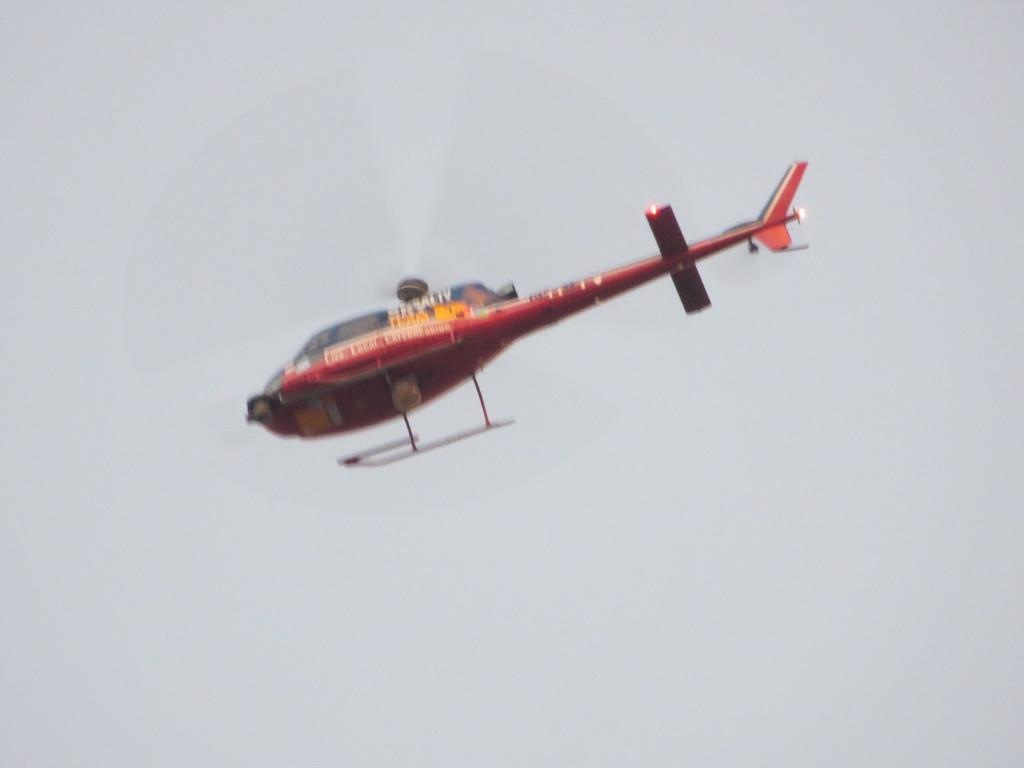What is the main subject of the image? The main subject of the image is a helicopter. What is the helicopter doing in the image? The helicopter is flying in the image. What can be seen in the background of the image? The sky is visible in the background of the image. What is the tendency of the dust in the image? There is no dust present in the image, so it is not possible to determine its tendency. 